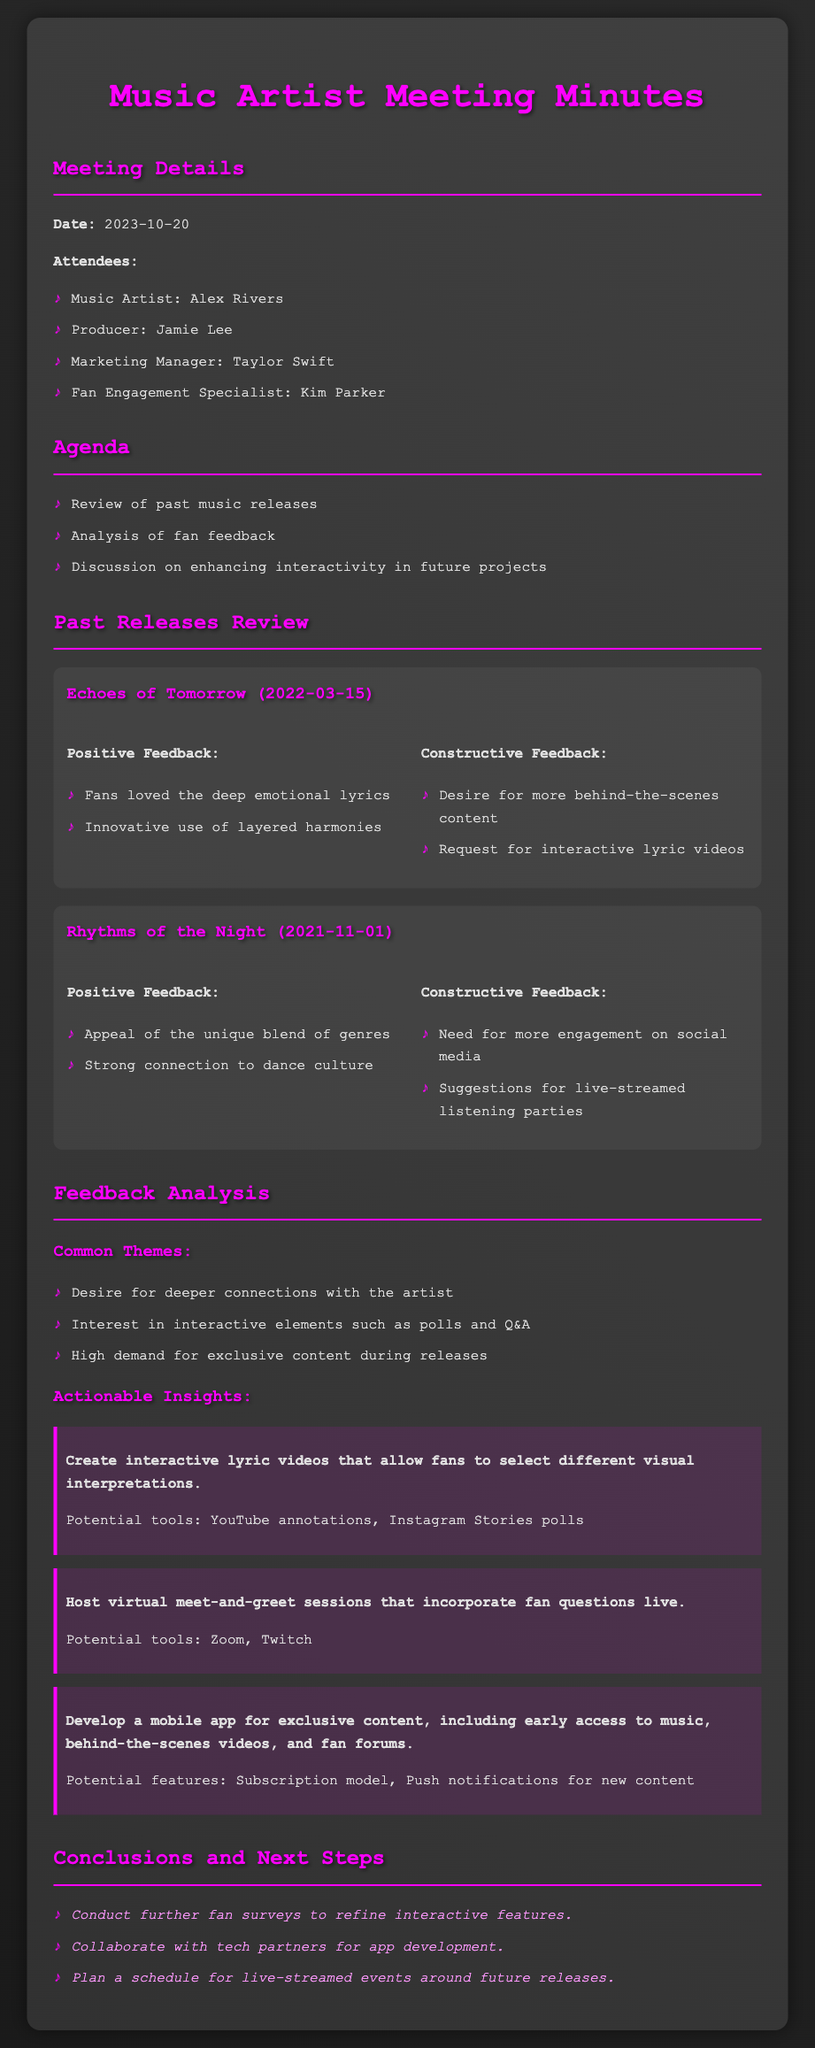What is the date of the meeting? The date of the meeting is listed in the document under the Meeting Details section.
Answer: 2023-10-20 Who is the Music Artist present in the meeting? The Music Artist present in the meeting is named in the Attendees list.
Answer: Alex Rivers What was a positive feedback for "Rhythms of the Night"? Positive feedback is mentioned in the feedback section for each release, showing fan sentiments.
Answer: Appeal of the unique blend of genres What is one of the actionable insights? The actionable insights are listed after the feedback analysis, summarizing suggested actions.
Answer: Create interactive lyric videos that allow fans to select different visual interpretations Which tool is suggested for hosting virtual meet-and-greet sessions? The tools for hosting virtual sessions are mentioned alongside each actionable insight.
Answer: Zoom What is one common theme from the feedback analysis? Common themes found in the feedback analysis reflect fans' desires and interests.
Answer: Desire for deeper connections with the artist How many attendees are listed in the meeting? The number of attendees can be counted from the list provided in the Attendees section.
Answer: 4 What is a next step mentioned in the conclusions? The next steps are outlined in the conclusions section, detailing future actions to take.
Answer: Conduct further fan surveys to refine interactive features 